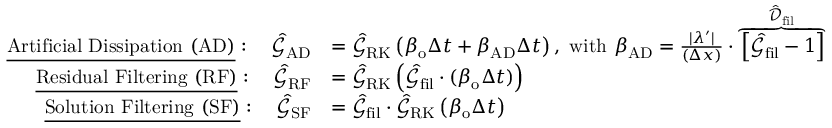<formula> <loc_0><loc_0><loc_500><loc_500>\begin{array} { r l } { \underline { A r t i f i c i a l D i s s i p a t i o n ( A D ) } \colon \quad \hat { \mathcal { G } } _ { A D } } & { = \hat { \mathcal { G } } _ { R K } \left ( \beta _ { o } \Delta t + \beta _ { A D } \Delta t \right ) , \ w i t h \ \beta _ { A D } = \frac { | \lambda ^ { \prime } | } { ( \Delta x ) } \cdot \overbrace { \left [ \hat { \mathcal { G } } _ { f i l } - 1 \right ] } ^ { \hat { \mathcal { D } } _ { f i l } } } \\ { \underline { R e s i d u a l F i l t e r i n g ( R F ) } \colon \quad \hat { \mathcal { G } } _ { R F } } & { = \hat { \mathcal { G } } _ { R K } \left ( \hat { \mathcal { G } } _ { f i l } \cdot ( \beta _ { o } \Delta t ) \right ) } \\ { \underline { S o l u t i o n F i l t e r i n g ( S F ) } \colon \quad \hat { \mathcal { G } } _ { S F } } & { = \hat { \mathcal { G } } _ { f i l } \cdot \hat { \mathcal { G } } _ { R K } \left ( \beta _ { o } \Delta t \right ) } \end{array}</formula> 